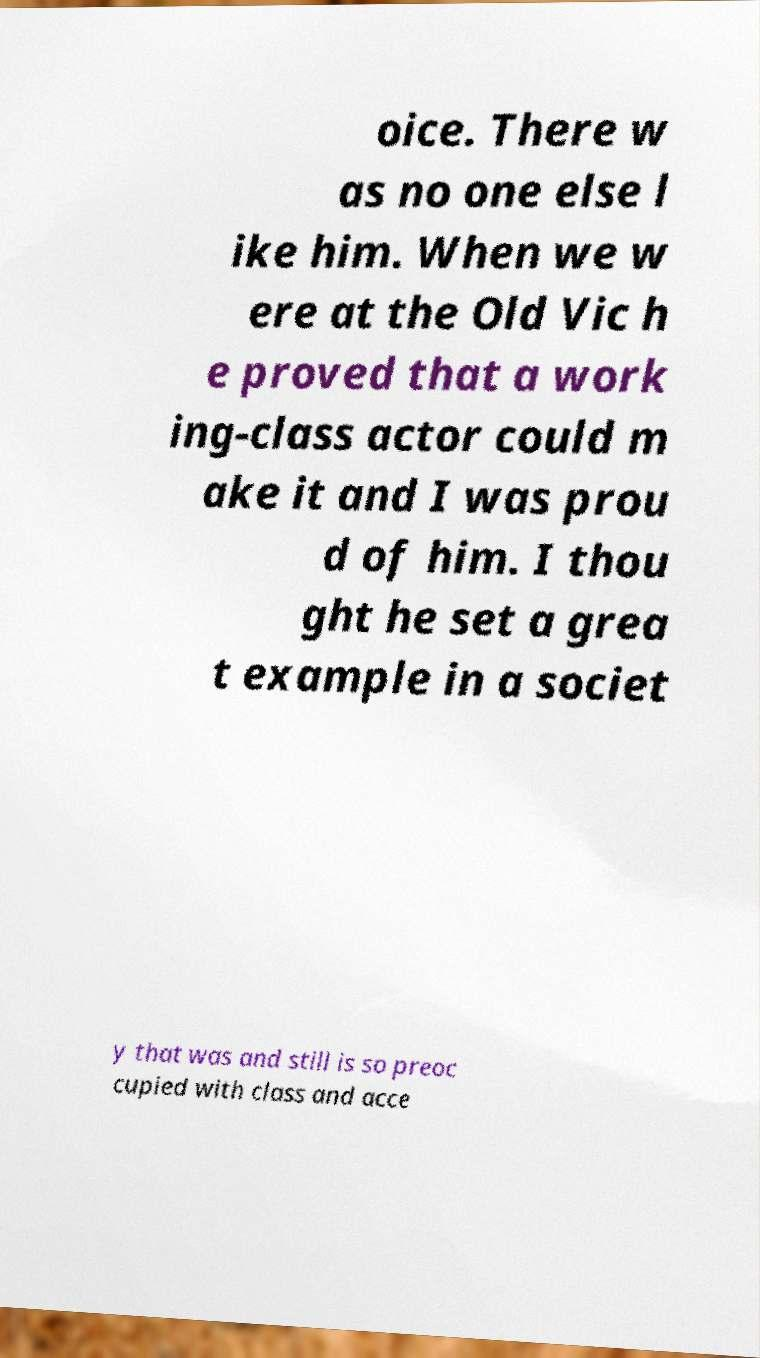Please identify and transcribe the text found in this image. oice. There w as no one else l ike him. When we w ere at the Old Vic h e proved that a work ing-class actor could m ake it and I was prou d of him. I thou ght he set a grea t example in a societ y that was and still is so preoc cupied with class and acce 